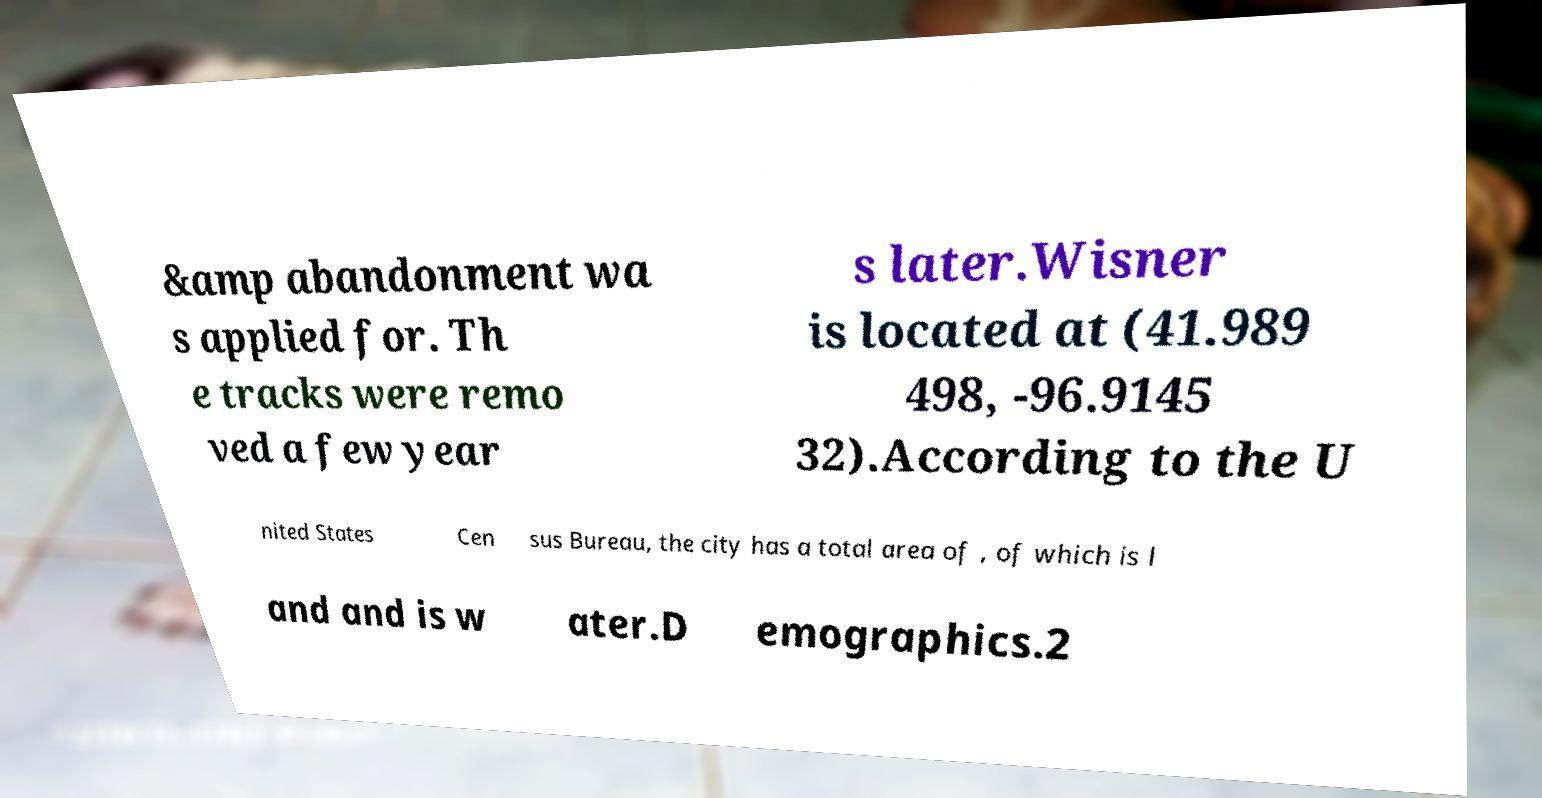Please read and relay the text visible in this image. What does it say? &amp abandonment wa s applied for. Th e tracks were remo ved a few year s later.Wisner is located at (41.989 498, -96.9145 32).According to the U nited States Cen sus Bureau, the city has a total area of , of which is l and and is w ater.D emographics.2 